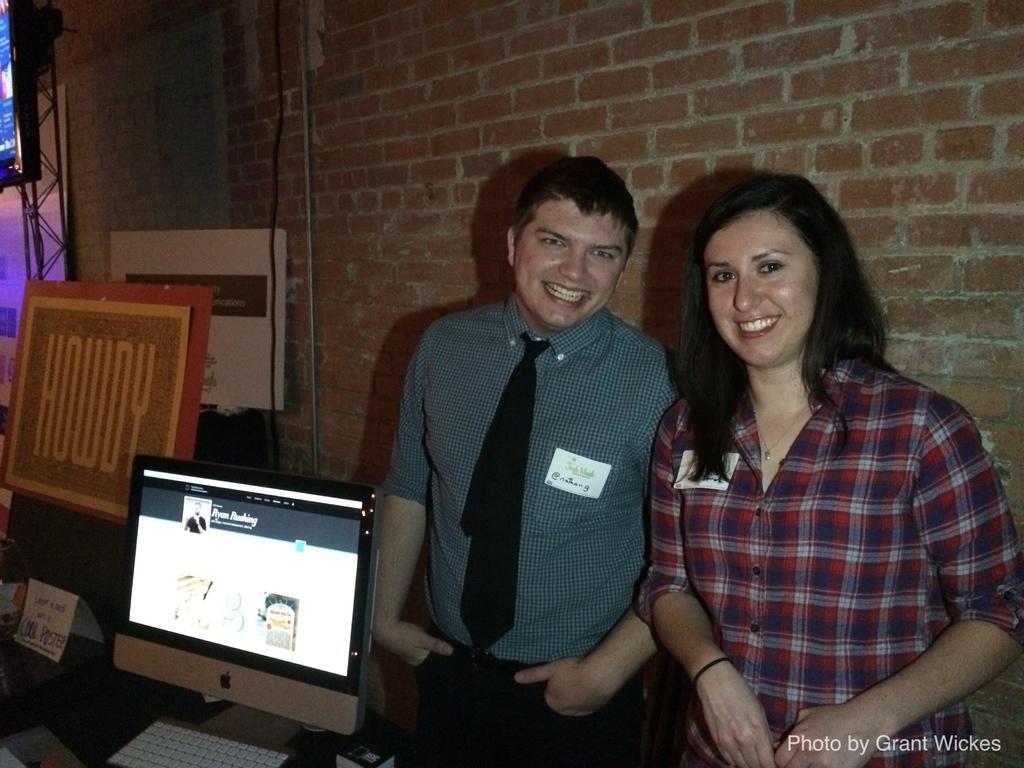Can you describe this image briefly? This is an inside view. On the right side, I can see a woman and a man are standing, smiling and giving pose for the picture. On the left side there is a table on which a monitor, keyboard, papers, a board and some other objects are placed. At the back of these people there is a wall. In the top left, I can see a screen is attached to a metal rod. In the bottom right, I can see some text. 